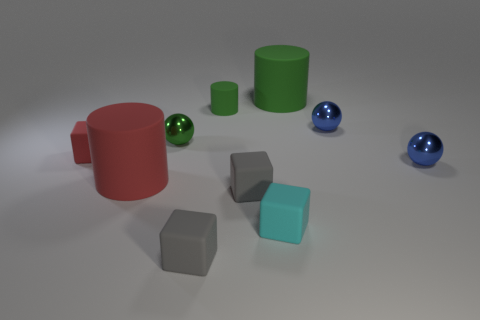Subtract 1 cubes. How many cubes are left? 3 Subtract all green blocks. Subtract all yellow cylinders. How many blocks are left? 4 Subtract all cylinders. How many objects are left? 7 Add 6 red matte cylinders. How many red matte cylinders are left? 7 Add 6 cylinders. How many cylinders exist? 9 Subtract 0 green cubes. How many objects are left? 10 Subtract all tiny cyan metallic things. Subtract all cylinders. How many objects are left? 7 